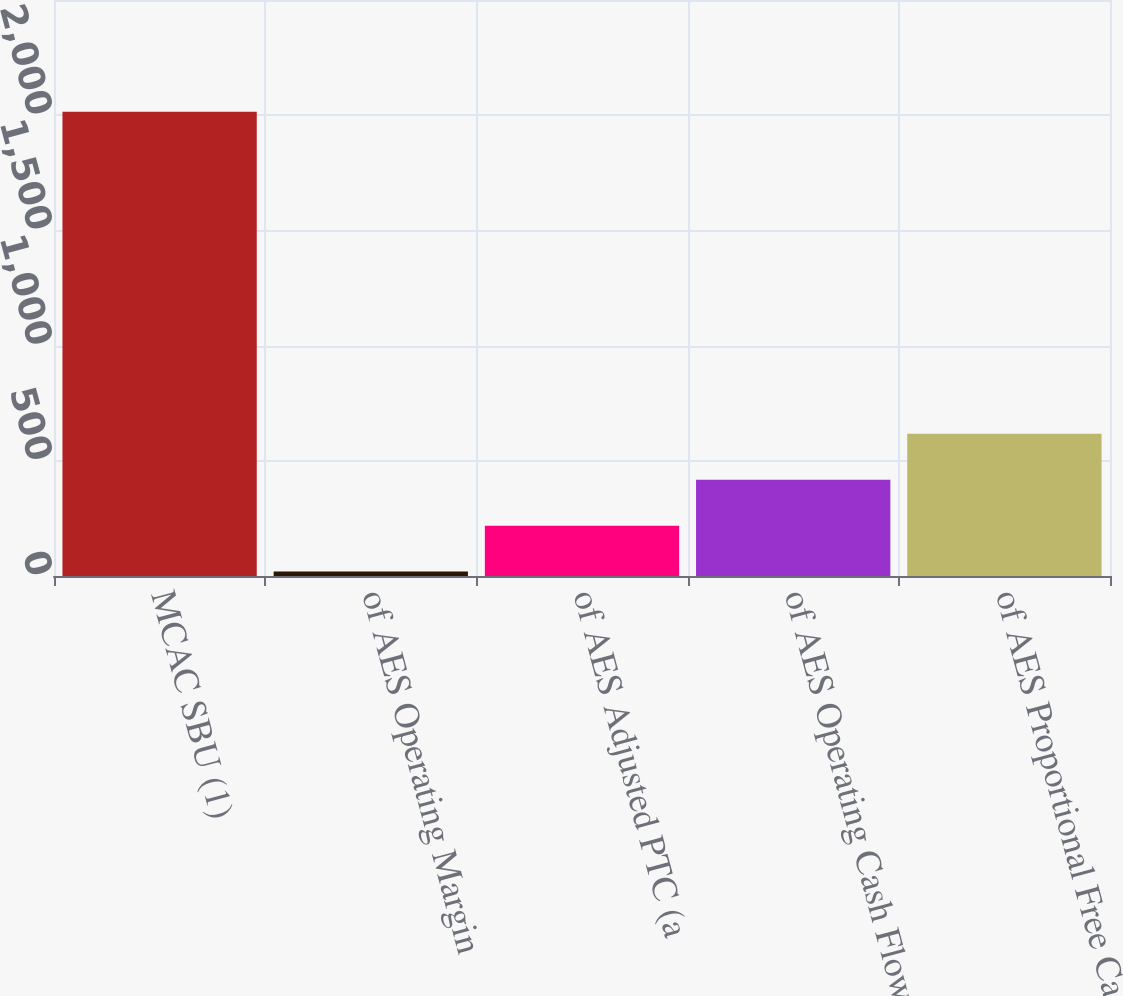Convert chart to OTSL. <chart><loc_0><loc_0><loc_500><loc_500><bar_chart><fcel>MCAC SBU (1)<fcel>of AES Operating Margin<fcel>of AES Adjusted PTC (a<fcel>of AES Operating Cash Flow<fcel>of AES Proportional Free Cash<nl><fcel>2015<fcel>19<fcel>218.6<fcel>418.2<fcel>617.8<nl></chart> 